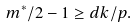Convert formula to latex. <formula><loc_0><loc_0><loc_500><loc_500>m ^ { * } / 2 - 1 \geq d k / p .</formula> 